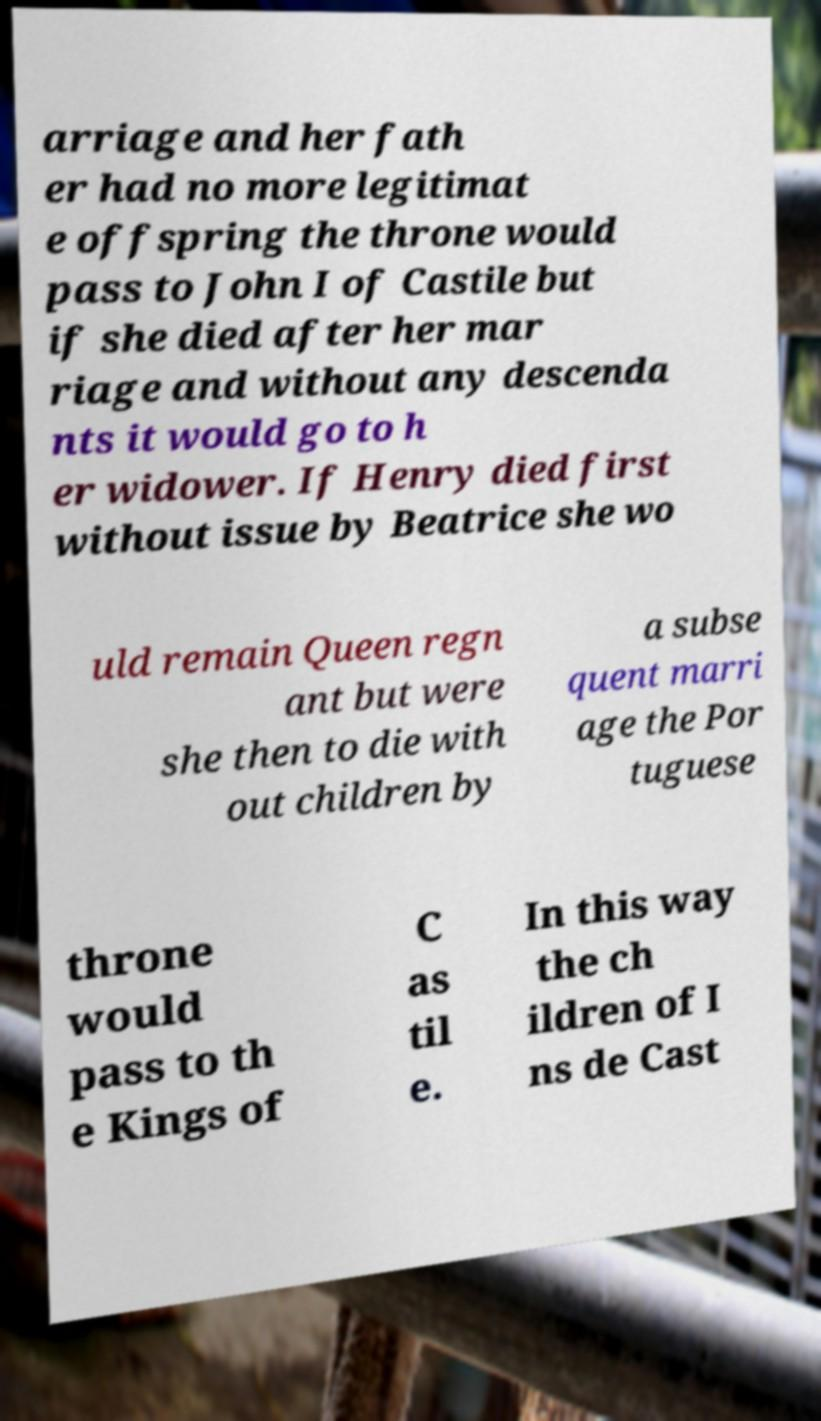There's text embedded in this image that I need extracted. Can you transcribe it verbatim? arriage and her fath er had no more legitimat e offspring the throne would pass to John I of Castile but if she died after her mar riage and without any descenda nts it would go to h er widower. If Henry died first without issue by Beatrice she wo uld remain Queen regn ant but were she then to die with out children by a subse quent marri age the Por tuguese throne would pass to th e Kings of C as til e. In this way the ch ildren of I ns de Cast 